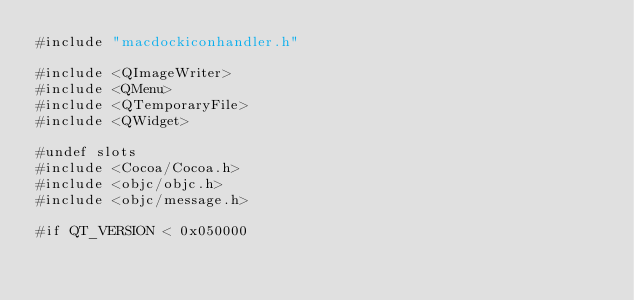<code> <loc_0><loc_0><loc_500><loc_500><_ObjectiveC_>#include "macdockiconhandler.h"

#include <QImageWriter>
#include <QMenu>
#include <QTemporaryFile>
#include <QWidget>

#undef slots
#include <Cocoa/Cocoa.h>
#include <objc/objc.h>
#include <objc/message.h>

#if QT_VERSION < 0x050000</code> 